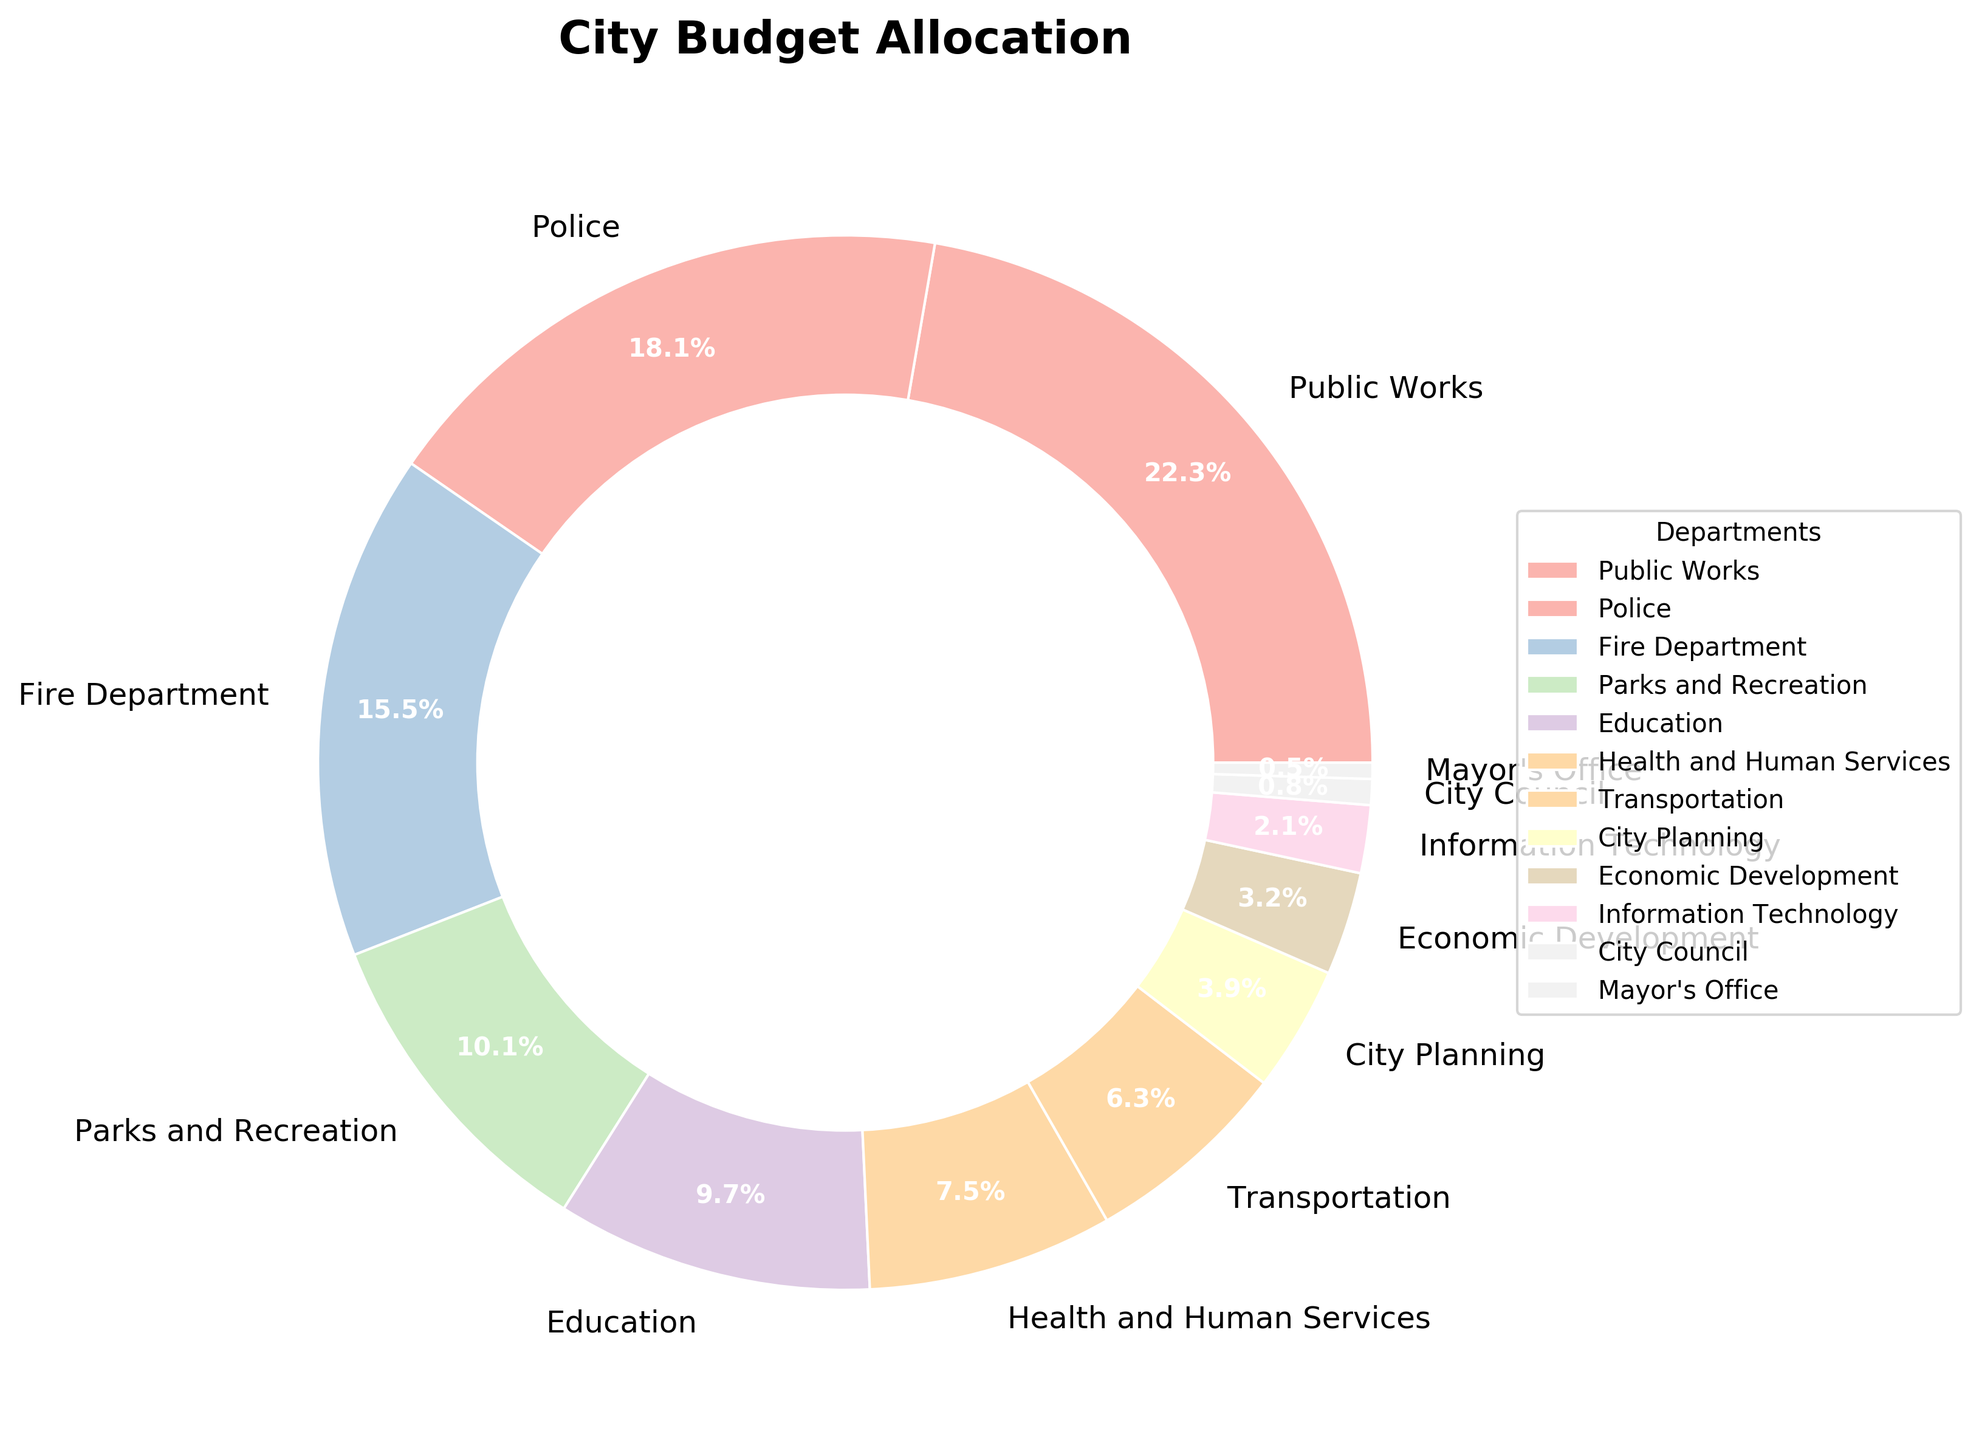What percentage of the city budget is allocated to the Police and the Fire Department combined? To find the combined budget percentage, add the percentage allocated to the Police (18.3%) and the Fire Department (15.7%). 18.3% + 15.7% = 34%
Answer: 34% Which department has the smallest budget allocation? Look at the pie chart and identify the department with the smallest slice. The Mayor's Office has the smallest allocation of 0.5%.
Answer: Mayor's Office How much more is allocated to Education compared to City Planning? Subtract the City Planning allocation (3.9%) from the Education allocation (9.8%). 9.8% - 3.9% = 5.9%
Answer: 5.9% Which department has the largest budget allocation and what is the percentage? Look for the department with the largest slice in the pie chart. The Public Works department has the largest allocation of 22.5%.
Answer: Public Works, 22.5% Is the combined budget for Health and Human Services, Transportation, and City Planning greater than the budget for Public Works? Add the budget percentages for Health and Human Services (7.6%), Transportation (6.4%), and City Planning (3.9%), and then compare it to the Public Works allocation. 7.6% + 6.4% + 3.9% = 17.9%, which is less than 22.5%.
Answer: No How many departments have a budget allocation greater than 10%? Count the departments with slices larger than 10%. There are three: Public Works (22.5%), Police (18.3%), and Fire Department (15.7%).
Answer: Three Among Parks and Recreation, Education, and Transportation, which department receives the smallest budget allocation? Compare the allocations: Parks and Recreation (10.2%), Education (9.8%), and Transportation (6.4%). Transportation has the smallest allocation.
Answer: Transportation What is the difference in allocation percentages between the department with the highest allocation and the department with the lowest allocation? Subtract the smallest allocation (Mayor's Office 0.5%) from the largest allocation (Public Works 22.5%). 22.5% - 0.5% = 22%
Answer: 22% What is the total allocation percentage for departments with less than 4% of the budget? Sum the percentages for City Planning (3.9%), Economic Development (3.2%), Information Technology (2.1%), City Council (0.8%), and Mayor's Office (0.5%). 3.9% + 3.2% + 2.1% + 0.8% + 0.5% = 10.5%
Answer: 10.5% 